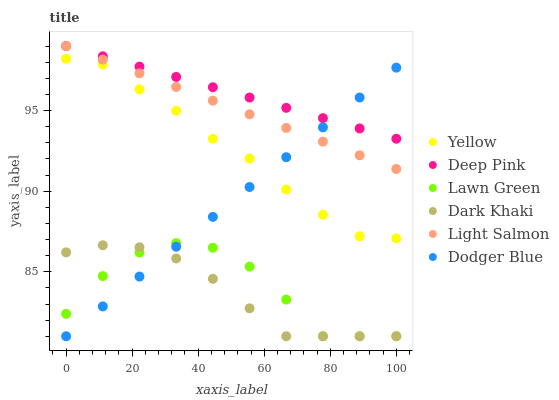Does Dark Khaki have the minimum area under the curve?
Answer yes or no. Yes. Does Deep Pink have the maximum area under the curve?
Answer yes or no. Yes. Does Light Salmon have the minimum area under the curve?
Answer yes or no. No. Does Light Salmon have the maximum area under the curve?
Answer yes or no. No. Is Deep Pink the smoothest?
Answer yes or no. Yes. Is Lawn Green the roughest?
Answer yes or no. Yes. Is Light Salmon the smoothest?
Answer yes or no. No. Is Light Salmon the roughest?
Answer yes or no. No. Does Lawn Green have the lowest value?
Answer yes or no. Yes. Does Light Salmon have the lowest value?
Answer yes or no. No. Does Deep Pink have the highest value?
Answer yes or no. Yes. Does Yellow have the highest value?
Answer yes or no. No. Is Lawn Green less than Light Salmon?
Answer yes or no. Yes. Is Deep Pink greater than Lawn Green?
Answer yes or no. Yes. Does Light Salmon intersect Dodger Blue?
Answer yes or no. Yes. Is Light Salmon less than Dodger Blue?
Answer yes or no. No. Is Light Salmon greater than Dodger Blue?
Answer yes or no. No. Does Lawn Green intersect Light Salmon?
Answer yes or no. No. 